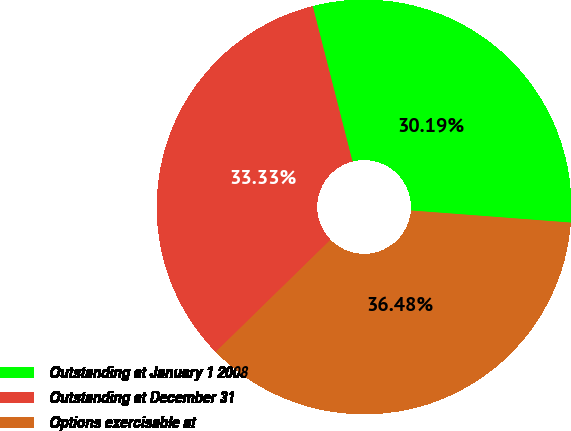Convert chart. <chart><loc_0><loc_0><loc_500><loc_500><pie_chart><fcel>Outstanding at January 1 2008<fcel>Outstanding at December 31<fcel>Options exercisable at<nl><fcel>30.19%<fcel>33.33%<fcel>36.48%<nl></chart> 